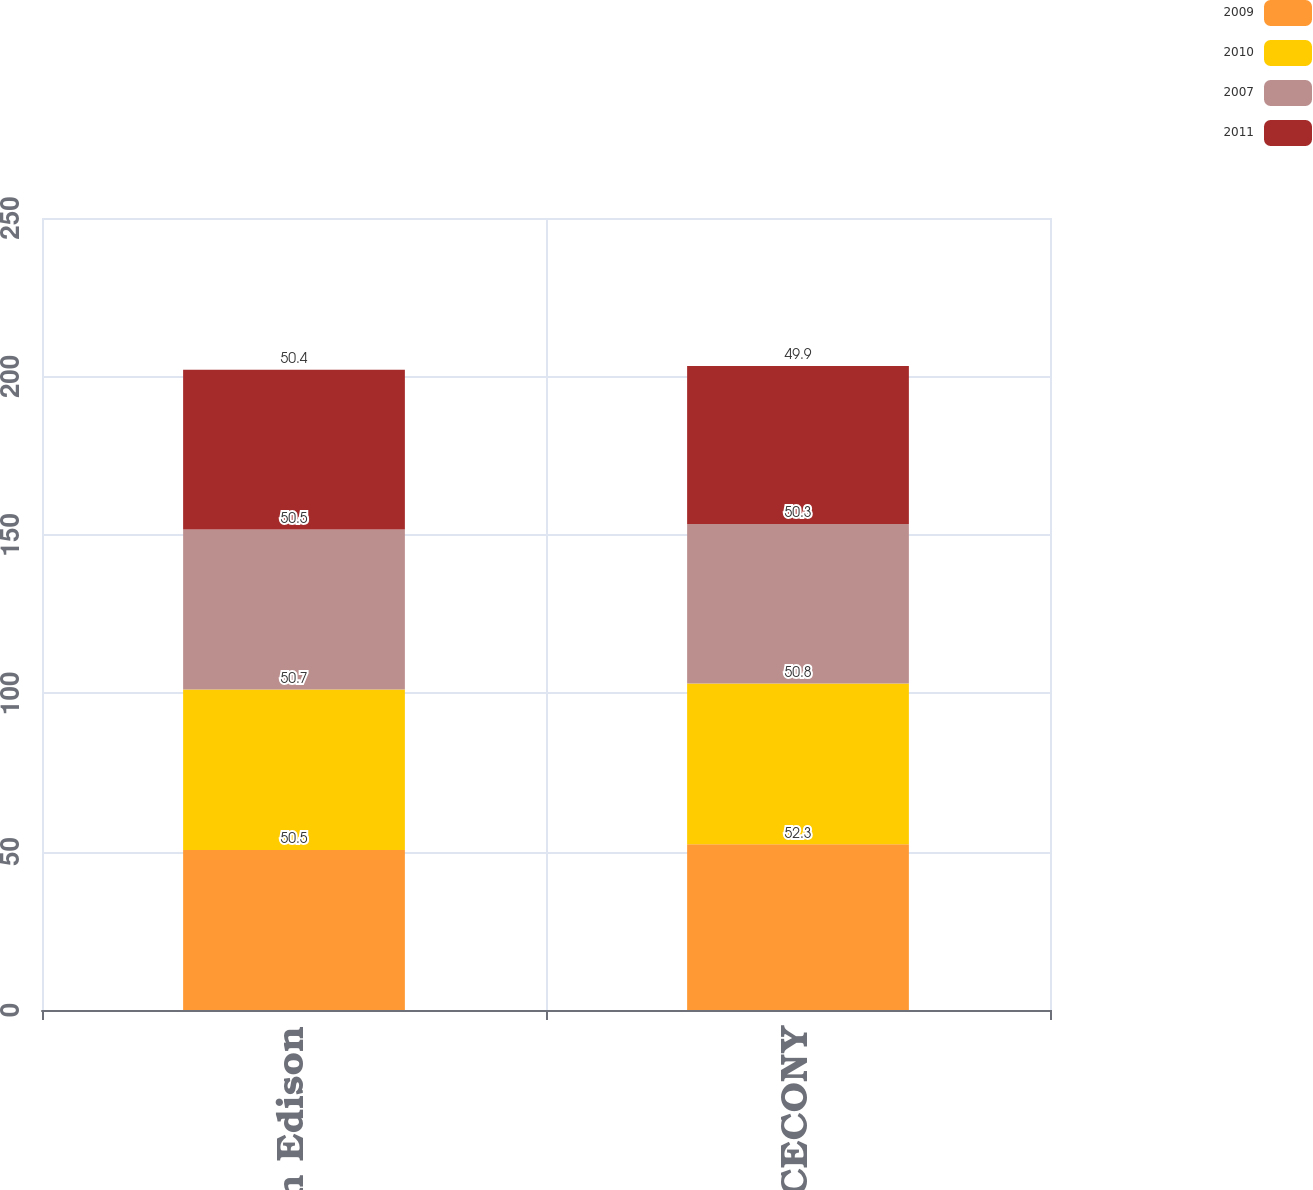Convert chart. <chart><loc_0><loc_0><loc_500><loc_500><stacked_bar_chart><ecel><fcel>Con Edison<fcel>CECONY<nl><fcel>2009<fcel>50.5<fcel>52.3<nl><fcel>2010<fcel>50.7<fcel>50.8<nl><fcel>2007<fcel>50.5<fcel>50.3<nl><fcel>2011<fcel>50.4<fcel>49.9<nl></chart> 